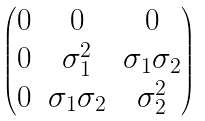<formula> <loc_0><loc_0><loc_500><loc_500>\begin{pmatrix} 0 & 0 & 0 \\ 0 & \sigma _ { 1 } ^ { 2 } & \sigma _ { 1 } \sigma _ { 2 } \\ 0 & \sigma _ { 1 } \sigma _ { 2 } & \sigma _ { 2 } ^ { 2 } \end{pmatrix}</formula> 